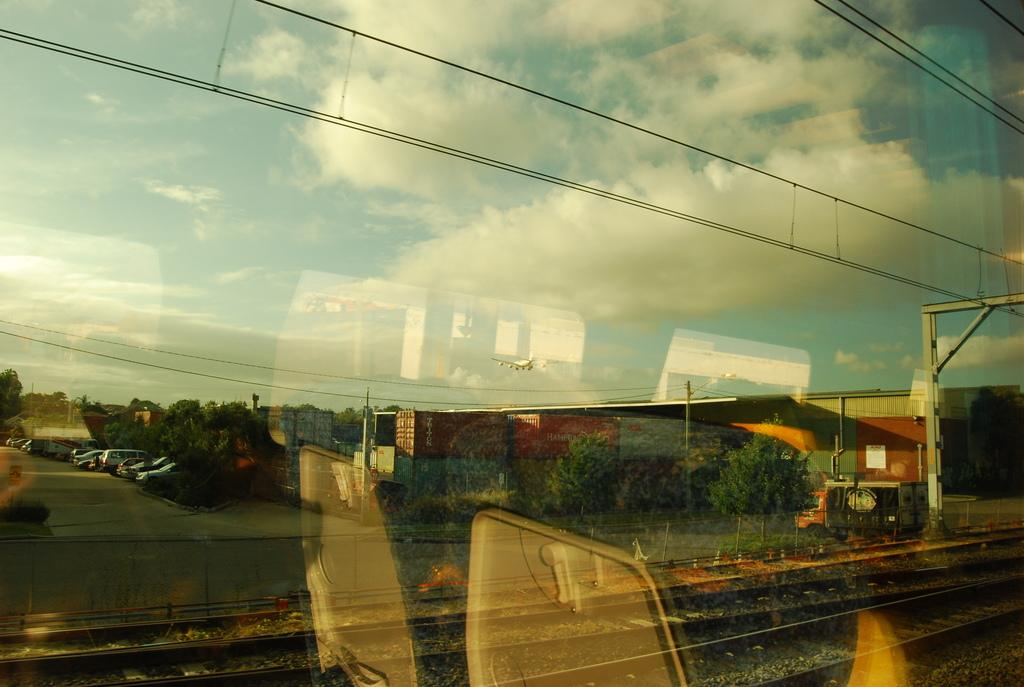What can be seen in the reflection of the image? There is a reflection of the sky in the image. What type of infrastructure is visible in the image? There is a railway track visible in the image. What other elements can be observed in the image due to their reflection on the glass? There are other unspecified elements visible in the image due to their reflection on the glass. What type of plough can be seen in the image? There is no plough present in the image. How does the reflection of the sky affect the temper of the glass in the image? The reflection of the sky does not affect the temper of the glass in the image; it is simply a reflection. 